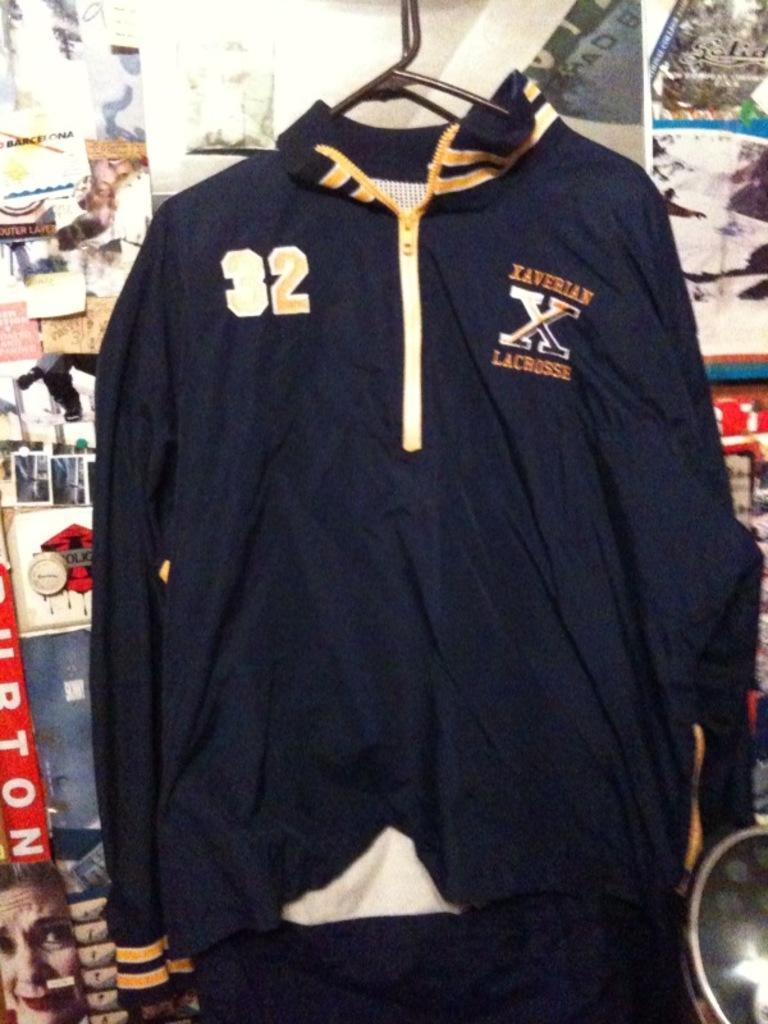Describe this image in one or two sentences. In this picture we can see a jacket here, in the background there are some papers pasted on the wall. 